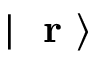Convert formula to latex. <formula><loc_0><loc_0><loc_500><loc_500>| r \rangle</formula> 